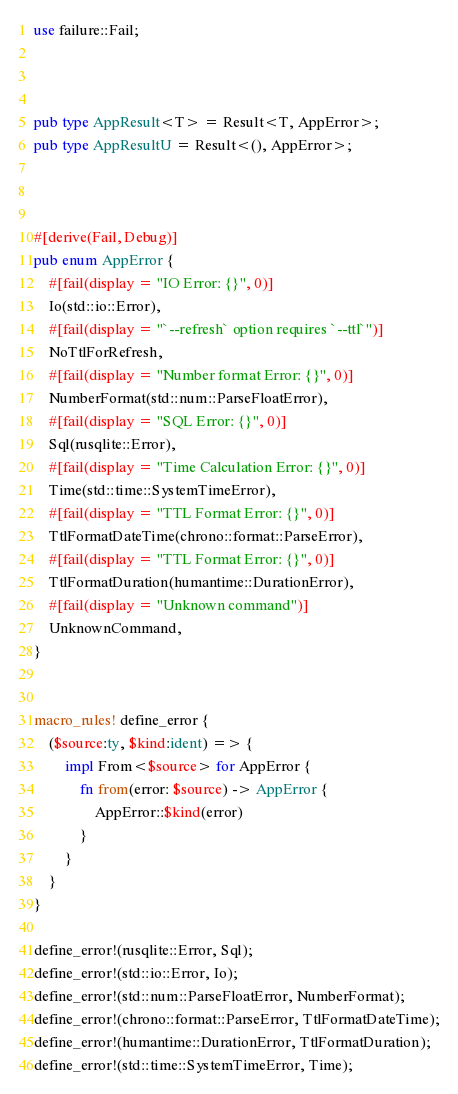<code> <loc_0><loc_0><loc_500><loc_500><_Rust_>
use failure::Fail;



pub type AppResult<T> = Result<T, AppError>;
pub type AppResultU = Result<(), AppError>;



#[derive(Fail, Debug)]
pub enum AppError {
    #[fail(display = "IO Error: {}", 0)]
    Io(std::io::Error),
    #[fail(display = "`--refresh` option requires `--ttl`")]
    NoTtlForRefresh,
    #[fail(display = "Number format Error: {}", 0)]
    NumberFormat(std::num::ParseFloatError),
    #[fail(display = "SQL Error: {}", 0)]
    Sql(rusqlite::Error),
    #[fail(display = "Time Calculation Error: {}", 0)]
    Time(std::time::SystemTimeError),
    #[fail(display = "TTL Format Error: {}", 0)]
    TtlFormatDateTime(chrono::format::ParseError),
    #[fail(display = "TTL Format Error: {}", 0)]
    TtlFormatDuration(humantime::DurationError),
    #[fail(display = "Unknown command")]
    UnknownCommand,
}


macro_rules! define_error {
    ($source:ty, $kind:ident) => {
        impl From<$source> for AppError {
            fn from(error: $source) -> AppError {
                AppError::$kind(error)
            }
        }
    }
}

define_error!(rusqlite::Error, Sql);
define_error!(std::io::Error, Io);
define_error!(std::num::ParseFloatError, NumberFormat);
define_error!(chrono::format::ParseError, TtlFormatDateTime);
define_error!(humantime::DurationError, TtlFormatDuration);
define_error!(std::time::SystemTimeError, Time);
</code> 